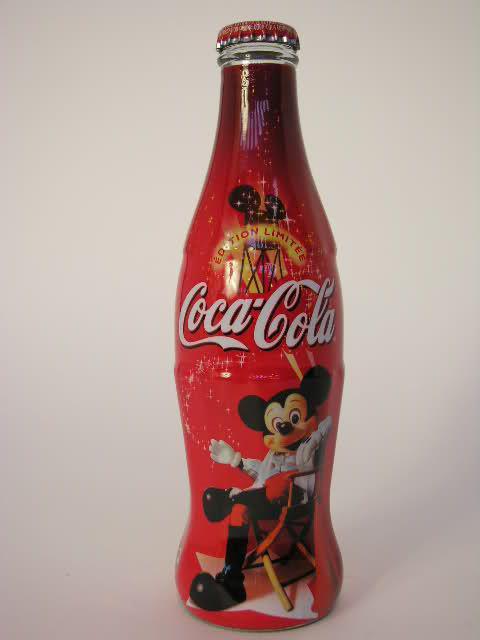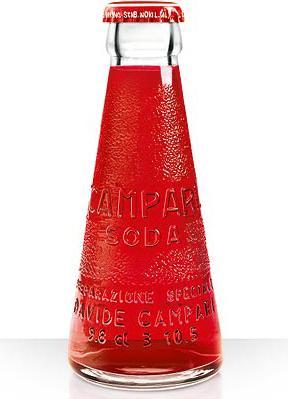The first image is the image on the left, the second image is the image on the right. For the images shown, is this caption "There are labels on each of the bottles." true? Answer yes or no. No. The first image is the image on the left, the second image is the image on the right. Assess this claim about the two images: "Each image shows one bottle with a cap on it, and one image features a bottle that tapers from its base, has a textured surface but no label, and contains a red liquid.". Correct or not? Answer yes or no. Yes. 